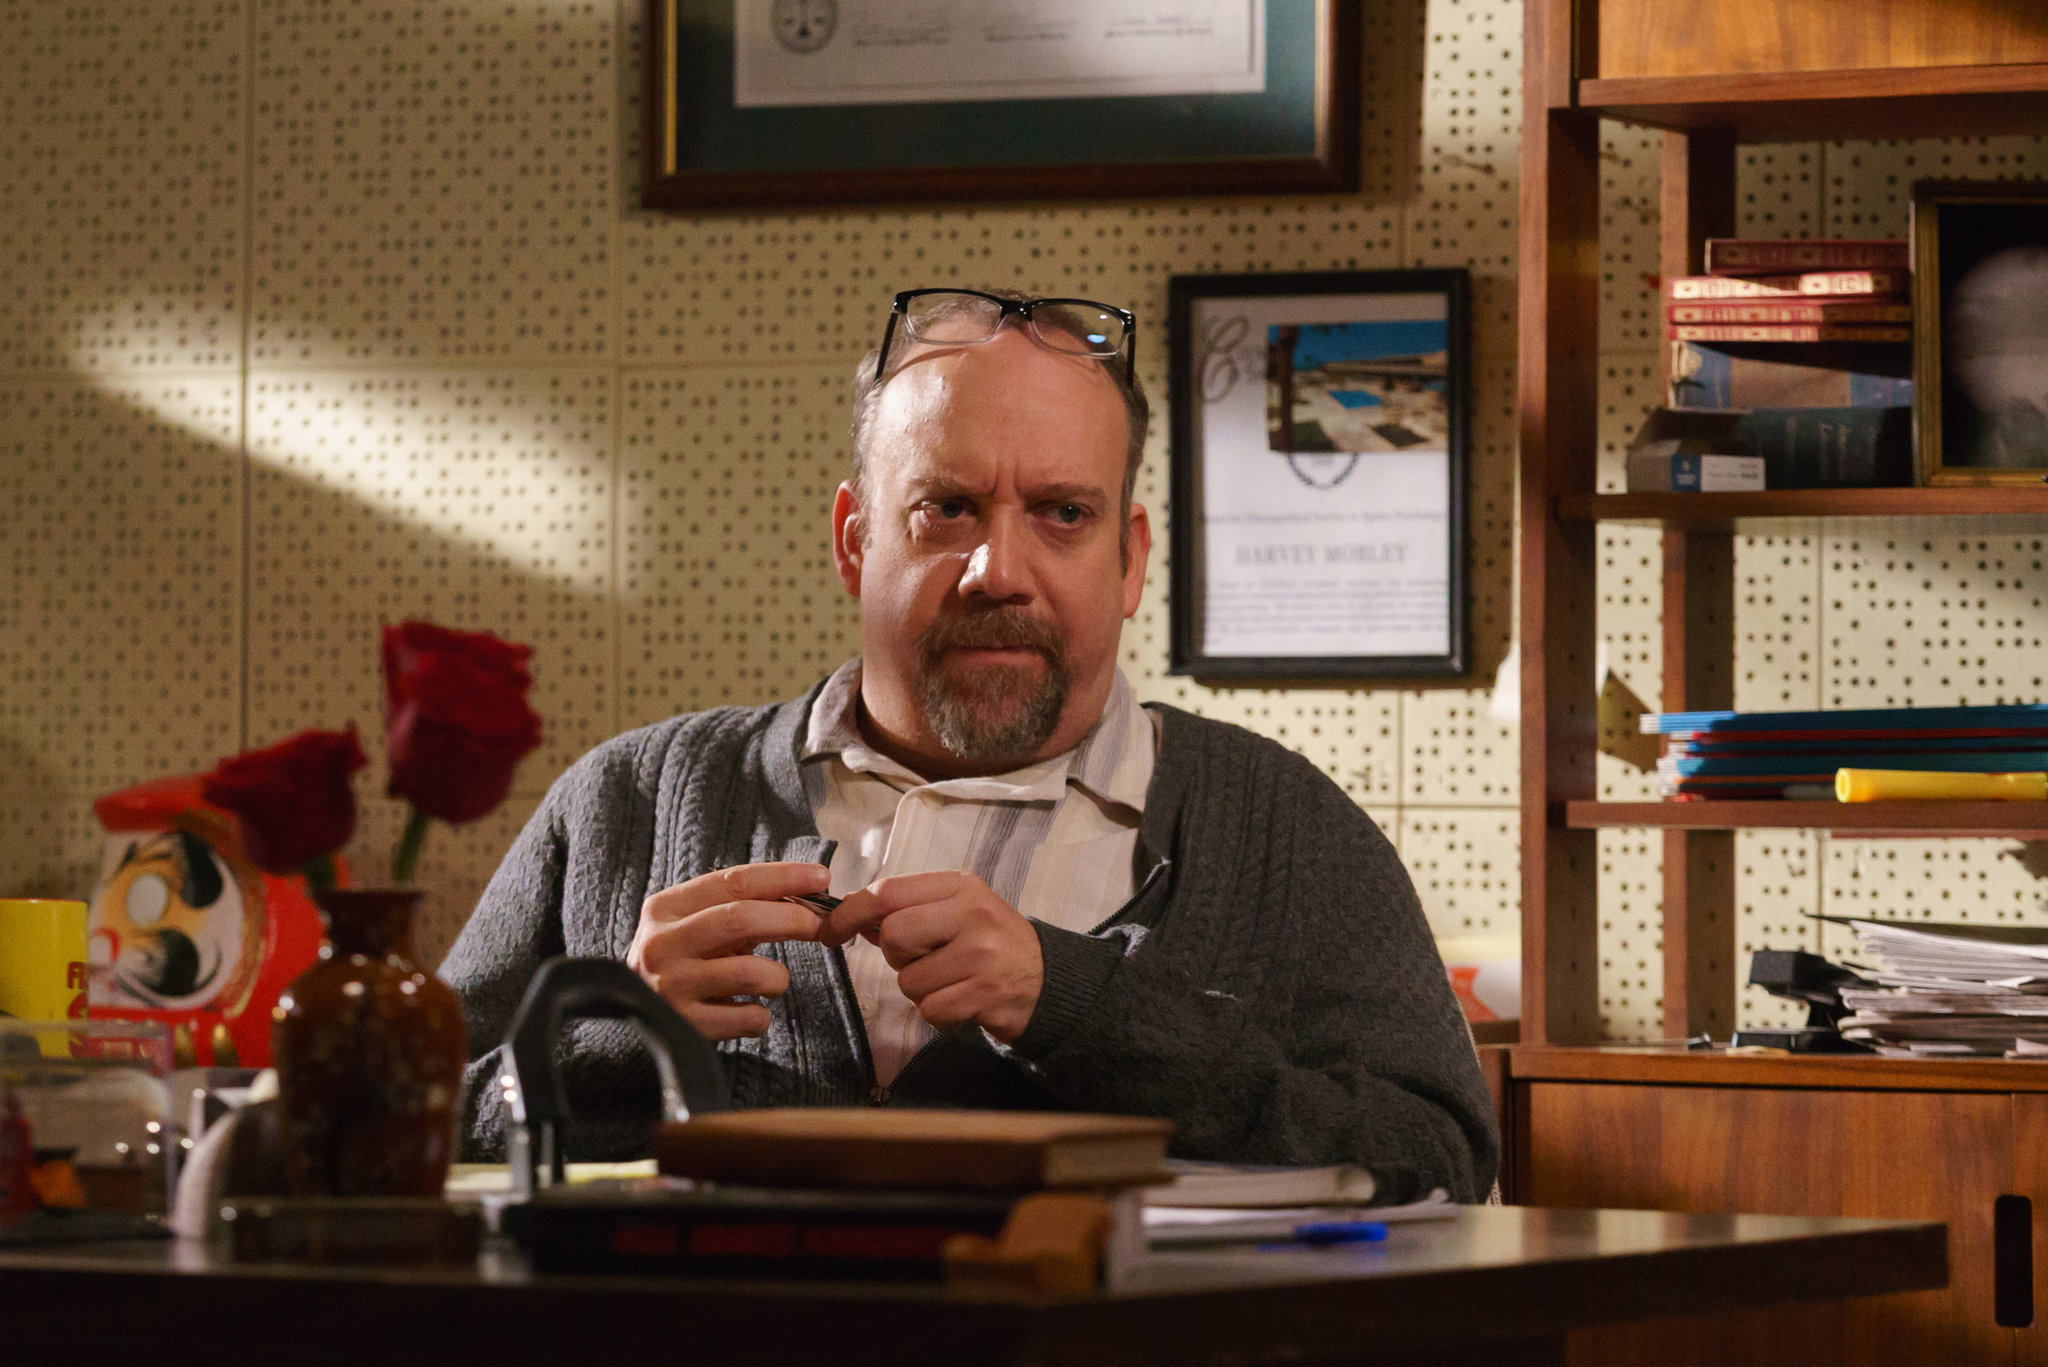What might the papers and books scattered around the desk suggest about the person in the image? The papers and books scattered around the desk suggest that the person is deeply engaged in his work, possibly involving research, writing, or administrative tasks. The variety and disarray of items indicate a busy professional who juggles multiple tasks and responsibilities simultaneously. The scene implies a blend of diligence and intellectual activity, potentially in a creative or academic field. 